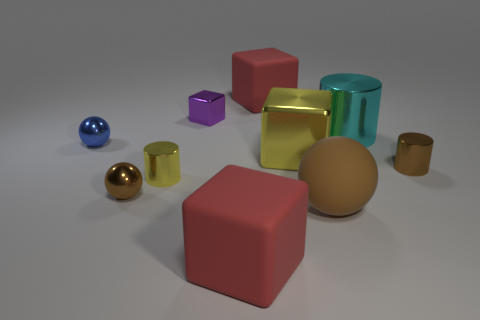What number of red things have the same shape as the cyan object?
Your response must be concise. 0. There is a object that is in front of the brown rubber sphere; does it have the same color as the matte object that is behind the large yellow metallic block?
Your answer should be very brief. Yes. What number of objects are metal cylinders or brown matte cylinders?
Provide a succinct answer. 3. What number of yellow things have the same material as the small yellow cylinder?
Provide a short and direct response. 1. Are there fewer big brown matte balls than big red matte blocks?
Keep it short and to the point. Yes. Is the red cube that is behind the large yellow object made of the same material as the blue ball?
Keep it short and to the point. No. What number of balls are brown rubber things or cyan shiny objects?
Keep it short and to the point. 1. What shape is the brown thing that is both right of the small brown metal ball and in front of the tiny brown cylinder?
Offer a very short reply. Sphere. The big matte block behind the tiny metal cylinder right of the big red matte block that is in front of the big yellow shiny thing is what color?
Ensure brevity in your answer.  Red. Are there fewer small metallic cubes that are on the left side of the yellow metallic cylinder than rubber cubes?
Your answer should be very brief. Yes. 